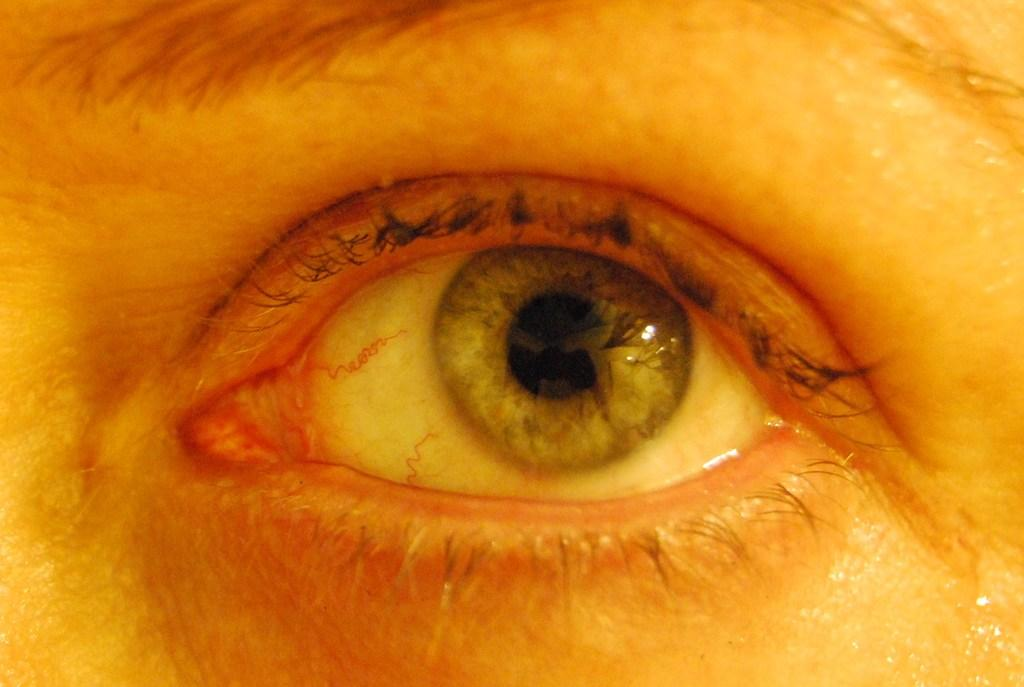What part of the human body is depicted in the image? The image contains a human eye. What other facial feature is present in the image? There is an eyebrow in the image. What covers the eye in the image? There is an eyelid in the image. What color are the nerves visible in the image? The nerves in the image are red. What color is the eyeball in the image? The eyeball in the image is black. What type of stocking is being worn by the nerve in the image? There are no stockings present in the image, as it features a human eye with nerves and other related features. 